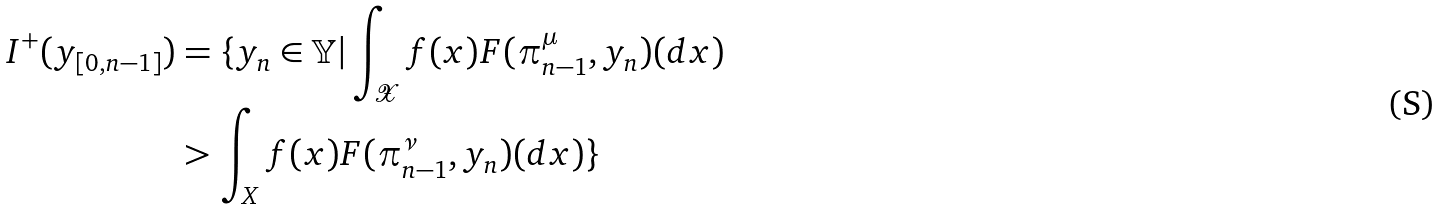<formula> <loc_0><loc_0><loc_500><loc_500>I ^ { + } ( y _ { [ 0 , n - 1 ] } ) & = \{ y _ { n } \in \mathbb { Y } | \int _ { \mathcal { X } } f ( x ) F ( \pi _ { n - 1 } ^ { \mu } , y _ { n } ) ( d x ) \\ & > \int _ { X } f ( x ) F ( \pi _ { n - 1 } ^ { \nu } , y _ { n } ) ( d x ) \}</formula> 